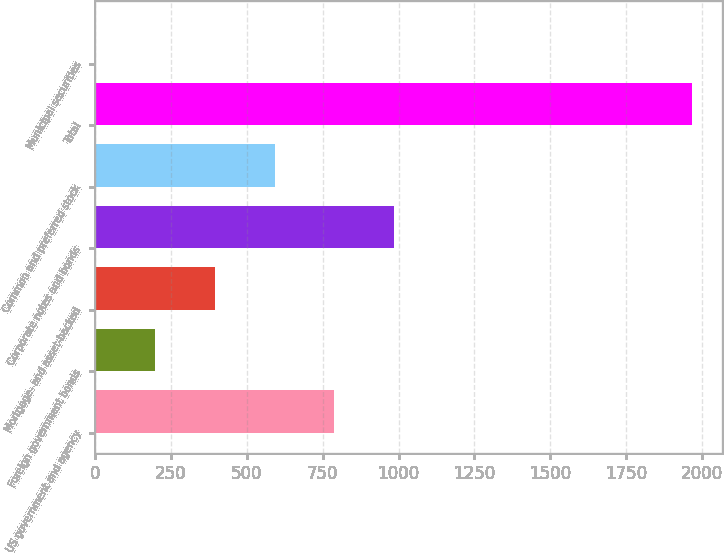Convert chart. <chart><loc_0><loc_0><loc_500><loc_500><bar_chart><fcel>US government and agency<fcel>Foreign government bonds<fcel>Mortgage- and asset-backed<fcel>Corporate notes and bonds<fcel>Common and preferred stock<fcel>Total<fcel>Municipal securities<nl><fcel>788.7<fcel>199.53<fcel>395.92<fcel>985.09<fcel>592.31<fcel>1967<fcel>3.14<nl></chart> 